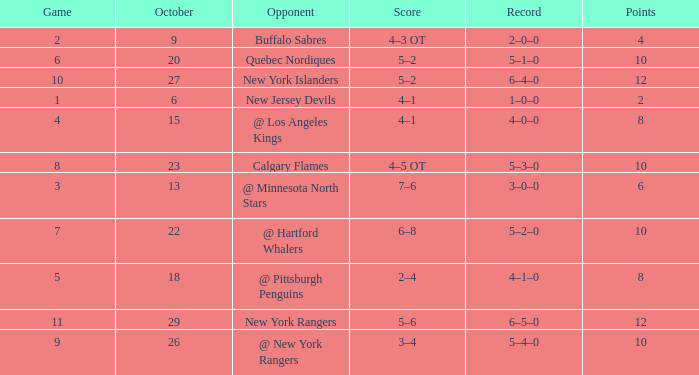Which October has a Record of 5–1–0, and a Game larger than 6? None. 